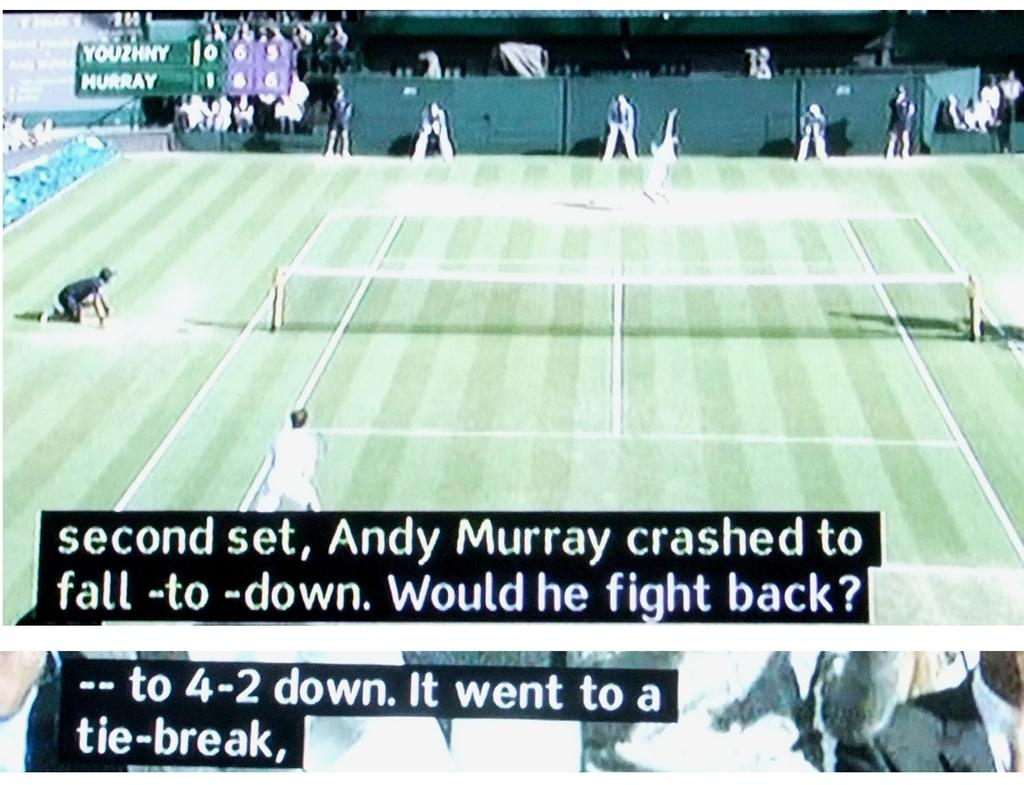<image>
Share a concise interpretation of the image provided. Screen that shows a tennis match and the score at 4-2. 